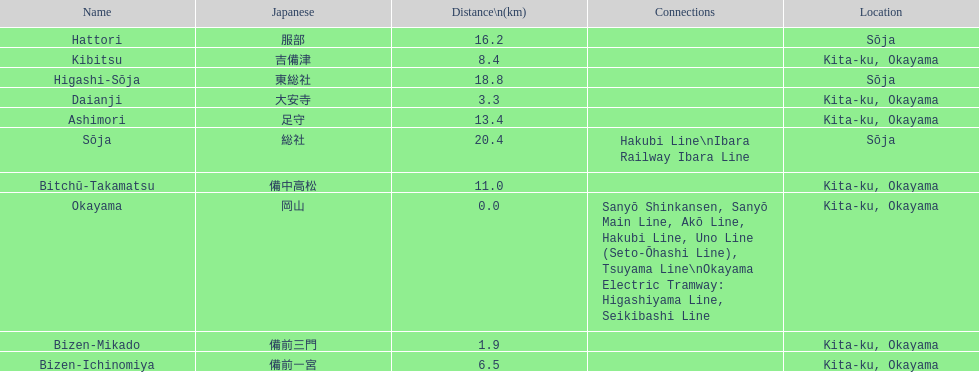Which has a distance less than 3.0 kilometers? Bizen-Mikado. 